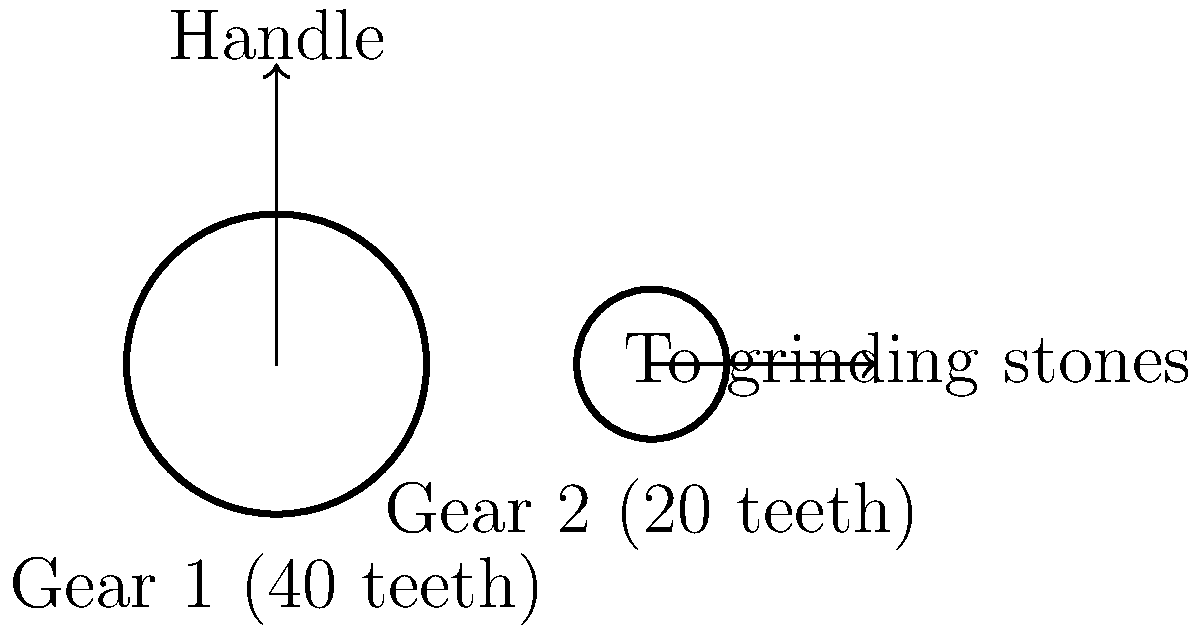In a manually operated grain mill designed for food self-sufficiency, Gear 1 (connected to the handle) has 40 teeth, while Gear 2 (connected to the grinding stones) has 20 teeth. If the handle is rotated at 60 RPM (revolutions per minute), what is the rotation speed of the grinding stones in RPM? To solve this problem, we'll use the principle of gear ratios. The ratio of the number of teeth on the gears is inversely proportional to their rotational speeds.

Step 1: Determine the gear ratio
Gear ratio = Number of teeth on Gear 1 / Number of teeth on Gear 2
Gear ratio = 40 / 20 = 2

Step 2: Set up the equation relating the rotational speeds
(RPM of Gear 1) / (RPM of Gear 2) = (Number of teeth on Gear 2) / (Number of teeth on Gear 1)

Step 3: Plug in the known values
60 / x = 20 / 40, where x is the RPM of Gear 2 (grinding stones)

Step 4: Simplify the equation
60 / x = 1 / 2

Step 5: Solve for x
x = 60 * 2 = 120

Therefore, when the handle (Gear 1) rotates at 60 RPM, the grinding stones (Gear 2) will rotate at 120 RPM.
Answer: 120 RPM 